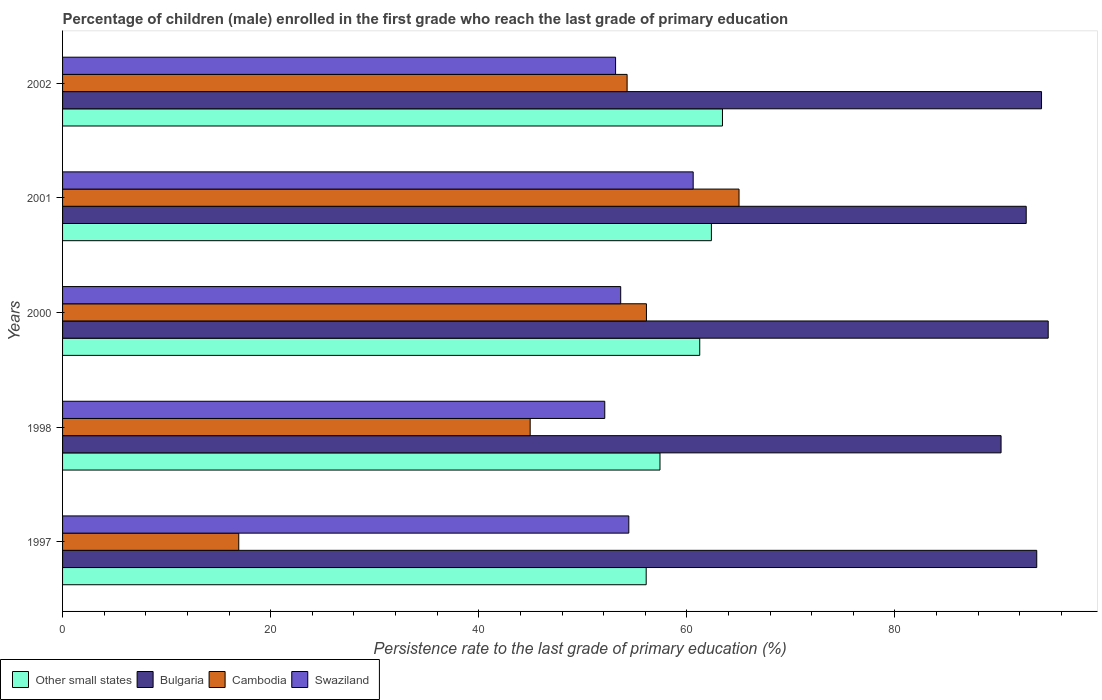How many different coloured bars are there?
Your response must be concise. 4. How many groups of bars are there?
Your response must be concise. 5. Are the number of bars per tick equal to the number of legend labels?
Offer a very short reply. Yes. Are the number of bars on each tick of the Y-axis equal?
Offer a terse response. Yes. What is the label of the 2nd group of bars from the top?
Your answer should be compact. 2001. In how many cases, is the number of bars for a given year not equal to the number of legend labels?
Offer a very short reply. 0. What is the persistence rate of children in Other small states in 1997?
Your answer should be compact. 56.09. Across all years, what is the maximum persistence rate of children in Cambodia?
Provide a succinct answer. 65.01. Across all years, what is the minimum persistence rate of children in Other small states?
Make the answer very short. 56.09. In which year was the persistence rate of children in Swaziland minimum?
Your response must be concise. 1998. What is the total persistence rate of children in Other small states in the graph?
Ensure brevity in your answer.  300.52. What is the difference between the persistence rate of children in Bulgaria in 2000 and that in 2002?
Offer a very short reply. 0.64. What is the difference between the persistence rate of children in Bulgaria in 1997 and the persistence rate of children in Cambodia in 2001?
Provide a short and direct response. 28.61. What is the average persistence rate of children in Other small states per year?
Your response must be concise. 60.1. In the year 1998, what is the difference between the persistence rate of children in Swaziland and persistence rate of children in Other small states?
Give a very brief answer. -5.31. In how many years, is the persistence rate of children in Bulgaria greater than 52 %?
Provide a short and direct response. 5. What is the ratio of the persistence rate of children in Cambodia in 1998 to that in 2000?
Your response must be concise. 0.8. Is the difference between the persistence rate of children in Swaziland in 2000 and 2001 greater than the difference between the persistence rate of children in Other small states in 2000 and 2001?
Make the answer very short. No. What is the difference between the highest and the second highest persistence rate of children in Other small states?
Ensure brevity in your answer.  1.07. What is the difference between the highest and the lowest persistence rate of children in Swaziland?
Offer a very short reply. 8.5. Is the sum of the persistence rate of children in Cambodia in 1997 and 1998 greater than the maximum persistence rate of children in Other small states across all years?
Give a very brief answer. No. What does the 3rd bar from the top in 1998 represents?
Give a very brief answer. Bulgaria. Is it the case that in every year, the sum of the persistence rate of children in Other small states and persistence rate of children in Bulgaria is greater than the persistence rate of children in Cambodia?
Provide a short and direct response. Yes. What is the difference between two consecutive major ticks on the X-axis?
Keep it short and to the point. 20. Are the values on the major ticks of X-axis written in scientific E-notation?
Your answer should be compact. No. Does the graph contain any zero values?
Offer a very short reply. No. How many legend labels are there?
Provide a succinct answer. 4. What is the title of the graph?
Make the answer very short. Percentage of children (male) enrolled in the first grade who reach the last grade of primary education. Does "Suriname" appear as one of the legend labels in the graph?
Keep it short and to the point. No. What is the label or title of the X-axis?
Provide a succinct answer. Persistence rate to the last grade of primary education (%). What is the Persistence rate to the last grade of primary education (%) of Other small states in 1997?
Provide a succinct answer. 56.09. What is the Persistence rate to the last grade of primary education (%) of Bulgaria in 1997?
Offer a terse response. 93.63. What is the Persistence rate to the last grade of primary education (%) of Cambodia in 1997?
Your response must be concise. 16.93. What is the Persistence rate to the last grade of primary education (%) of Swaziland in 1997?
Your answer should be very brief. 54.42. What is the Persistence rate to the last grade of primary education (%) of Other small states in 1998?
Keep it short and to the point. 57.42. What is the Persistence rate to the last grade of primary education (%) in Bulgaria in 1998?
Your answer should be compact. 90.2. What is the Persistence rate to the last grade of primary education (%) in Cambodia in 1998?
Provide a short and direct response. 44.94. What is the Persistence rate to the last grade of primary education (%) in Swaziland in 1998?
Provide a succinct answer. 52.11. What is the Persistence rate to the last grade of primary education (%) of Other small states in 2000?
Give a very brief answer. 61.24. What is the Persistence rate to the last grade of primary education (%) of Bulgaria in 2000?
Your answer should be compact. 94.73. What is the Persistence rate to the last grade of primary education (%) in Cambodia in 2000?
Make the answer very short. 56.11. What is the Persistence rate to the last grade of primary education (%) in Swaziland in 2000?
Provide a succinct answer. 53.64. What is the Persistence rate to the last grade of primary education (%) in Other small states in 2001?
Your response must be concise. 62.36. What is the Persistence rate to the last grade of primary education (%) of Bulgaria in 2001?
Your answer should be compact. 92.61. What is the Persistence rate to the last grade of primary education (%) in Cambodia in 2001?
Offer a very short reply. 65.01. What is the Persistence rate to the last grade of primary education (%) in Swaziland in 2001?
Provide a short and direct response. 60.61. What is the Persistence rate to the last grade of primary education (%) in Other small states in 2002?
Provide a short and direct response. 63.42. What is the Persistence rate to the last grade of primary education (%) of Bulgaria in 2002?
Offer a very short reply. 94.09. What is the Persistence rate to the last grade of primary education (%) in Cambodia in 2002?
Make the answer very short. 54.26. What is the Persistence rate to the last grade of primary education (%) of Swaziland in 2002?
Provide a succinct answer. 53.15. Across all years, what is the maximum Persistence rate to the last grade of primary education (%) of Other small states?
Your answer should be compact. 63.42. Across all years, what is the maximum Persistence rate to the last grade of primary education (%) of Bulgaria?
Provide a short and direct response. 94.73. Across all years, what is the maximum Persistence rate to the last grade of primary education (%) in Cambodia?
Provide a short and direct response. 65.01. Across all years, what is the maximum Persistence rate to the last grade of primary education (%) of Swaziland?
Your response must be concise. 60.61. Across all years, what is the minimum Persistence rate to the last grade of primary education (%) of Other small states?
Make the answer very short. 56.09. Across all years, what is the minimum Persistence rate to the last grade of primary education (%) in Bulgaria?
Make the answer very short. 90.2. Across all years, what is the minimum Persistence rate to the last grade of primary education (%) of Cambodia?
Your response must be concise. 16.93. Across all years, what is the minimum Persistence rate to the last grade of primary education (%) in Swaziland?
Give a very brief answer. 52.11. What is the total Persistence rate to the last grade of primary education (%) of Other small states in the graph?
Ensure brevity in your answer.  300.52. What is the total Persistence rate to the last grade of primary education (%) in Bulgaria in the graph?
Keep it short and to the point. 465.25. What is the total Persistence rate to the last grade of primary education (%) in Cambodia in the graph?
Keep it short and to the point. 237.26. What is the total Persistence rate to the last grade of primary education (%) of Swaziland in the graph?
Your answer should be compact. 273.93. What is the difference between the Persistence rate to the last grade of primary education (%) of Other small states in 1997 and that in 1998?
Ensure brevity in your answer.  -1.33. What is the difference between the Persistence rate to the last grade of primary education (%) in Bulgaria in 1997 and that in 1998?
Provide a succinct answer. 3.43. What is the difference between the Persistence rate to the last grade of primary education (%) in Cambodia in 1997 and that in 1998?
Your answer should be very brief. -28.01. What is the difference between the Persistence rate to the last grade of primary education (%) in Swaziland in 1997 and that in 1998?
Your answer should be very brief. 2.31. What is the difference between the Persistence rate to the last grade of primary education (%) in Other small states in 1997 and that in 2000?
Give a very brief answer. -5.15. What is the difference between the Persistence rate to the last grade of primary education (%) of Bulgaria in 1997 and that in 2000?
Your response must be concise. -1.1. What is the difference between the Persistence rate to the last grade of primary education (%) of Cambodia in 1997 and that in 2000?
Your answer should be very brief. -39.18. What is the difference between the Persistence rate to the last grade of primary education (%) in Swaziland in 1997 and that in 2000?
Your answer should be compact. 0.78. What is the difference between the Persistence rate to the last grade of primary education (%) of Other small states in 1997 and that in 2001?
Keep it short and to the point. -6.27. What is the difference between the Persistence rate to the last grade of primary education (%) of Bulgaria in 1997 and that in 2001?
Provide a short and direct response. 1.01. What is the difference between the Persistence rate to the last grade of primary education (%) of Cambodia in 1997 and that in 2001?
Offer a very short reply. -48.08. What is the difference between the Persistence rate to the last grade of primary education (%) of Swaziland in 1997 and that in 2001?
Offer a very short reply. -6.19. What is the difference between the Persistence rate to the last grade of primary education (%) of Other small states in 1997 and that in 2002?
Offer a terse response. -7.33. What is the difference between the Persistence rate to the last grade of primary education (%) of Bulgaria in 1997 and that in 2002?
Ensure brevity in your answer.  -0.46. What is the difference between the Persistence rate to the last grade of primary education (%) in Cambodia in 1997 and that in 2002?
Give a very brief answer. -37.32. What is the difference between the Persistence rate to the last grade of primary education (%) of Swaziland in 1997 and that in 2002?
Make the answer very short. 1.27. What is the difference between the Persistence rate to the last grade of primary education (%) in Other small states in 1998 and that in 2000?
Ensure brevity in your answer.  -3.82. What is the difference between the Persistence rate to the last grade of primary education (%) of Bulgaria in 1998 and that in 2000?
Ensure brevity in your answer.  -4.53. What is the difference between the Persistence rate to the last grade of primary education (%) of Cambodia in 1998 and that in 2000?
Your answer should be very brief. -11.17. What is the difference between the Persistence rate to the last grade of primary education (%) in Swaziland in 1998 and that in 2000?
Make the answer very short. -1.53. What is the difference between the Persistence rate to the last grade of primary education (%) in Other small states in 1998 and that in 2001?
Your response must be concise. -4.94. What is the difference between the Persistence rate to the last grade of primary education (%) in Bulgaria in 1998 and that in 2001?
Your answer should be very brief. -2.42. What is the difference between the Persistence rate to the last grade of primary education (%) of Cambodia in 1998 and that in 2001?
Provide a short and direct response. -20.07. What is the difference between the Persistence rate to the last grade of primary education (%) of Swaziland in 1998 and that in 2001?
Keep it short and to the point. -8.5. What is the difference between the Persistence rate to the last grade of primary education (%) of Other small states in 1998 and that in 2002?
Provide a succinct answer. -6. What is the difference between the Persistence rate to the last grade of primary education (%) of Bulgaria in 1998 and that in 2002?
Provide a short and direct response. -3.89. What is the difference between the Persistence rate to the last grade of primary education (%) of Cambodia in 1998 and that in 2002?
Keep it short and to the point. -9.32. What is the difference between the Persistence rate to the last grade of primary education (%) in Swaziland in 1998 and that in 2002?
Offer a terse response. -1.04. What is the difference between the Persistence rate to the last grade of primary education (%) in Other small states in 2000 and that in 2001?
Offer a terse response. -1.12. What is the difference between the Persistence rate to the last grade of primary education (%) in Bulgaria in 2000 and that in 2001?
Your response must be concise. 2.11. What is the difference between the Persistence rate to the last grade of primary education (%) in Cambodia in 2000 and that in 2001?
Provide a short and direct response. -8.9. What is the difference between the Persistence rate to the last grade of primary education (%) of Swaziland in 2000 and that in 2001?
Provide a succinct answer. -6.97. What is the difference between the Persistence rate to the last grade of primary education (%) in Other small states in 2000 and that in 2002?
Offer a terse response. -2.18. What is the difference between the Persistence rate to the last grade of primary education (%) of Bulgaria in 2000 and that in 2002?
Make the answer very short. 0.64. What is the difference between the Persistence rate to the last grade of primary education (%) in Cambodia in 2000 and that in 2002?
Give a very brief answer. 1.86. What is the difference between the Persistence rate to the last grade of primary education (%) of Swaziland in 2000 and that in 2002?
Give a very brief answer. 0.49. What is the difference between the Persistence rate to the last grade of primary education (%) of Other small states in 2001 and that in 2002?
Provide a short and direct response. -1.07. What is the difference between the Persistence rate to the last grade of primary education (%) in Bulgaria in 2001 and that in 2002?
Your answer should be very brief. -1.47. What is the difference between the Persistence rate to the last grade of primary education (%) in Cambodia in 2001 and that in 2002?
Your answer should be compact. 10.76. What is the difference between the Persistence rate to the last grade of primary education (%) in Swaziland in 2001 and that in 2002?
Offer a very short reply. 7.46. What is the difference between the Persistence rate to the last grade of primary education (%) of Other small states in 1997 and the Persistence rate to the last grade of primary education (%) of Bulgaria in 1998?
Give a very brief answer. -34.11. What is the difference between the Persistence rate to the last grade of primary education (%) of Other small states in 1997 and the Persistence rate to the last grade of primary education (%) of Cambodia in 1998?
Make the answer very short. 11.15. What is the difference between the Persistence rate to the last grade of primary education (%) of Other small states in 1997 and the Persistence rate to the last grade of primary education (%) of Swaziland in 1998?
Ensure brevity in your answer.  3.98. What is the difference between the Persistence rate to the last grade of primary education (%) in Bulgaria in 1997 and the Persistence rate to the last grade of primary education (%) in Cambodia in 1998?
Offer a terse response. 48.69. What is the difference between the Persistence rate to the last grade of primary education (%) in Bulgaria in 1997 and the Persistence rate to the last grade of primary education (%) in Swaziland in 1998?
Your response must be concise. 41.52. What is the difference between the Persistence rate to the last grade of primary education (%) of Cambodia in 1997 and the Persistence rate to the last grade of primary education (%) of Swaziland in 1998?
Your answer should be very brief. -35.18. What is the difference between the Persistence rate to the last grade of primary education (%) of Other small states in 1997 and the Persistence rate to the last grade of primary education (%) of Bulgaria in 2000?
Make the answer very short. -38.64. What is the difference between the Persistence rate to the last grade of primary education (%) of Other small states in 1997 and the Persistence rate to the last grade of primary education (%) of Cambodia in 2000?
Ensure brevity in your answer.  -0.02. What is the difference between the Persistence rate to the last grade of primary education (%) of Other small states in 1997 and the Persistence rate to the last grade of primary education (%) of Swaziland in 2000?
Keep it short and to the point. 2.45. What is the difference between the Persistence rate to the last grade of primary education (%) of Bulgaria in 1997 and the Persistence rate to the last grade of primary education (%) of Cambodia in 2000?
Provide a succinct answer. 37.51. What is the difference between the Persistence rate to the last grade of primary education (%) of Bulgaria in 1997 and the Persistence rate to the last grade of primary education (%) of Swaziland in 2000?
Make the answer very short. 39.99. What is the difference between the Persistence rate to the last grade of primary education (%) in Cambodia in 1997 and the Persistence rate to the last grade of primary education (%) in Swaziland in 2000?
Your response must be concise. -36.71. What is the difference between the Persistence rate to the last grade of primary education (%) in Other small states in 1997 and the Persistence rate to the last grade of primary education (%) in Bulgaria in 2001?
Provide a succinct answer. -36.52. What is the difference between the Persistence rate to the last grade of primary education (%) in Other small states in 1997 and the Persistence rate to the last grade of primary education (%) in Cambodia in 2001?
Ensure brevity in your answer.  -8.92. What is the difference between the Persistence rate to the last grade of primary education (%) of Other small states in 1997 and the Persistence rate to the last grade of primary education (%) of Swaziland in 2001?
Your answer should be compact. -4.52. What is the difference between the Persistence rate to the last grade of primary education (%) in Bulgaria in 1997 and the Persistence rate to the last grade of primary education (%) in Cambodia in 2001?
Offer a very short reply. 28.61. What is the difference between the Persistence rate to the last grade of primary education (%) in Bulgaria in 1997 and the Persistence rate to the last grade of primary education (%) in Swaziland in 2001?
Ensure brevity in your answer.  33.02. What is the difference between the Persistence rate to the last grade of primary education (%) in Cambodia in 1997 and the Persistence rate to the last grade of primary education (%) in Swaziland in 2001?
Provide a succinct answer. -43.67. What is the difference between the Persistence rate to the last grade of primary education (%) in Other small states in 1997 and the Persistence rate to the last grade of primary education (%) in Bulgaria in 2002?
Offer a terse response. -38. What is the difference between the Persistence rate to the last grade of primary education (%) of Other small states in 1997 and the Persistence rate to the last grade of primary education (%) of Cambodia in 2002?
Provide a short and direct response. 1.83. What is the difference between the Persistence rate to the last grade of primary education (%) of Other small states in 1997 and the Persistence rate to the last grade of primary education (%) of Swaziland in 2002?
Your answer should be compact. 2.94. What is the difference between the Persistence rate to the last grade of primary education (%) in Bulgaria in 1997 and the Persistence rate to the last grade of primary education (%) in Cambodia in 2002?
Your answer should be very brief. 39.37. What is the difference between the Persistence rate to the last grade of primary education (%) of Bulgaria in 1997 and the Persistence rate to the last grade of primary education (%) of Swaziland in 2002?
Ensure brevity in your answer.  40.48. What is the difference between the Persistence rate to the last grade of primary education (%) of Cambodia in 1997 and the Persistence rate to the last grade of primary education (%) of Swaziland in 2002?
Make the answer very short. -36.21. What is the difference between the Persistence rate to the last grade of primary education (%) of Other small states in 1998 and the Persistence rate to the last grade of primary education (%) of Bulgaria in 2000?
Your response must be concise. -37.31. What is the difference between the Persistence rate to the last grade of primary education (%) in Other small states in 1998 and the Persistence rate to the last grade of primary education (%) in Cambodia in 2000?
Your answer should be compact. 1.3. What is the difference between the Persistence rate to the last grade of primary education (%) in Other small states in 1998 and the Persistence rate to the last grade of primary education (%) in Swaziland in 2000?
Ensure brevity in your answer.  3.78. What is the difference between the Persistence rate to the last grade of primary education (%) of Bulgaria in 1998 and the Persistence rate to the last grade of primary education (%) of Cambodia in 2000?
Give a very brief answer. 34.08. What is the difference between the Persistence rate to the last grade of primary education (%) in Bulgaria in 1998 and the Persistence rate to the last grade of primary education (%) in Swaziland in 2000?
Offer a terse response. 36.56. What is the difference between the Persistence rate to the last grade of primary education (%) of Cambodia in 1998 and the Persistence rate to the last grade of primary education (%) of Swaziland in 2000?
Provide a short and direct response. -8.7. What is the difference between the Persistence rate to the last grade of primary education (%) in Other small states in 1998 and the Persistence rate to the last grade of primary education (%) in Bulgaria in 2001?
Your response must be concise. -35.2. What is the difference between the Persistence rate to the last grade of primary education (%) in Other small states in 1998 and the Persistence rate to the last grade of primary education (%) in Cambodia in 2001?
Offer a terse response. -7.6. What is the difference between the Persistence rate to the last grade of primary education (%) of Other small states in 1998 and the Persistence rate to the last grade of primary education (%) of Swaziland in 2001?
Keep it short and to the point. -3.19. What is the difference between the Persistence rate to the last grade of primary education (%) in Bulgaria in 1998 and the Persistence rate to the last grade of primary education (%) in Cambodia in 2001?
Your response must be concise. 25.18. What is the difference between the Persistence rate to the last grade of primary education (%) of Bulgaria in 1998 and the Persistence rate to the last grade of primary education (%) of Swaziland in 2001?
Ensure brevity in your answer.  29.59. What is the difference between the Persistence rate to the last grade of primary education (%) in Cambodia in 1998 and the Persistence rate to the last grade of primary education (%) in Swaziland in 2001?
Your response must be concise. -15.67. What is the difference between the Persistence rate to the last grade of primary education (%) of Other small states in 1998 and the Persistence rate to the last grade of primary education (%) of Bulgaria in 2002?
Provide a short and direct response. -36.67. What is the difference between the Persistence rate to the last grade of primary education (%) of Other small states in 1998 and the Persistence rate to the last grade of primary education (%) of Cambodia in 2002?
Provide a short and direct response. 3.16. What is the difference between the Persistence rate to the last grade of primary education (%) in Other small states in 1998 and the Persistence rate to the last grade of primary education (%) in Swaziland in 2002?
Give a very brief answer. 4.27. What is the difference between the Persistence rate to the last grade of primary education (%) in Bulgaria in 1998 and the Persistence rate to the last grade of primary education (%) in Cambodia in 2002?
Offer a terse response. 35.94. What is the difference between the Persistence rate to the last grade of primary education (%) in Bulgaria in 1998 and the Persistence rate to the last grade of primary education (%) in Swaziland in 2002?
Your response must be concise. 37.05. What is the difference between the Persistence rate to the last grade of primary education (%) of Cambodia in 1998 and the Persistence rate to the last grade of primary education (%) of Swaziland in 2002?
Offer a very short reply. -8.21. What is the difference between the Persistence rate to the last grade of primary education (%) of Other small states in 2000 and the Persistence rate to the last grade of primary education (%) of Bulgaria in 2001?
Offer a very short reply. -31.38. What is the difference between the Persistence rate to the last grade of primary education (%) of Other small states in 2000 and the Persistence rate to the last grade of primary education (%) of Cambodia in 2001?
Offer a very short reply. -3.78. What is the difference between the Persistence rate to the last grade of primary education (%) in Other small states in 2000 and the Persistence rate to the last grade of primary education (%) in Swaziland in 2001?
Your answer should be very brief. 0.63. What is the difference between the Persistence rate to the last grade of primary education (%) of Bulgaria in 2000 and the Persistence rate to the last grade of primary education (%) of Cambodia in 2001?
Ensure brevity in your answer.  29.71. What is the difference between the Persistence rate to the last grade of primary education (%) of Bulgaria in 2000 and the Persistence rate to the last grade of primary education (%) of Swaziland in 2001?
Give a very brief answer. 34.12. What is the difference between the Persistence rate to the last grade of primary education (%) in Cambodia in 2000 and the Persistence rate to the last grade of primary education (%) in Swaziland in 2001?
Keep it short and to the point. -4.49. What is the difference between the Persistence rate to the last grade of primary education (%) of Other small states in 2000 and the Persistence rate to the last grade of primary education (%) of Bulgaria in 2002?
Provide a short and direct response. -32.85. What is the difference between the Persistence rate to the last grade of primary education (%) in Other small states in 2000 and the Persistence rate to the last grade of primary education (%) in Cambodia in 2002?
Offer a terse response. 6.98. What is the difference between the Persistence rate to the last grade of primary education (%) of Other small states in 2000 and the Persistence rate to the last grade of primary education (%) of Swaziland in 2002?
Provide a succinct answer. 8.09. What is the difference between the Persistence rate to the last grade of primary education (%) of Bulgaria in 2000 and the Persistence rate to the last grade of primary education (%) of Cambodia in 2002?
Give a very brief answer. 40.47. What is the difference between the Persistence rate to the last grade of primary education (%) of Bulgaria in 2000 and the Persistence rate to the last grade of primary education (%) of Swaziland in 2002?
Your answer should be very brief. 41.58. What is the difference between the Persistence rate to the last grade of primary education (%) of Cambodia in 2000 and the Persistence rate to the last grade of primary education (%) of Swaziland in 2002?
Give a very brief answer. 2.97. What is the difference between the Persistence rate to the last grade of primary education (%) in Other small states in 2001 and the Persistence rate to the last grade of primary education (%) in Bulgaria in 2002?
Give a very brief answer. -31.73. What is the difference between the Persistence rate to the last grade of primary education (%) of Other small states in 2001 and the Persistence rate to the last grade of primary education (%) of Cambodia in 2002?
Your answer should be very brief. 8.1. What is the difference between the Persistence rate to the last grade of primary education (%) of Other small states in 2001 and the Persistence rate to the last grade of primary education (%) of Swaziland in 2002?
Make the answer very short. 9.21. What is the difference between the Persistence rate to the last grade of primary education (%) in Bulgaria in 2001 and the Persistence rate to the last grade of primary education (%) in Cambodia in 2002?
Your answer should be very brief. 38.36. What is the difference between the Persistence rate to the last grade of primary education (%) of Bulgaria in 2001 and the Persistence rate to the last grade of primary education (%) of Swaziland in 2002?
Your answer should be compact. 39.47. What is the difference between the Persistence rate to the last grade of primary education (%) of Cambodia in 2001 and the Persistence rate to the last grade of primary education (%) of Swaziland in 2002?
Your answer should be very brief. 11.86. What is the average Persistence rate to the last grade of primary education (%) of Other small states per year?
Ensure brevity in your answer.  60.1. What is the average Persistence rate to the last grade of primary education (%) of Bulgaria per year?
Provide a succinct answer. 93.05. What is the average Persistence rate to the last grade of primary education (%) in Cambodia per year?
Your answer should be very brief. 47.45. What is the average Persistence rate to the last grade of primary education (%) of Swaziland per year?
Offer a very short reply. 54.79. In the year 1997, what is the difference between the Persistence rate to the last grade of primary education (%) in Other small states and Persistence rate to the last grade of primary education (%) in Bulgaria?
Offer a terse response. -37.54. In the year 1997, what is the difference between the Persistence rate to the last grade of primary education (%) in Other small states and Persistence rate to the last grade of primary education (%) in Cambodia?
Give a very brief answer. 39.16. In the year 1997, what is the difference between the Persistence rate to the last grade of primary education (%) of Other small states and Persistence rate to the last grade of primary education (%) of Swaziland?
Your answer should be very brief. 1.67. In the year 1997, what is the difference between the Persistence rate to the last grade of primary education (%) in Bulgaria and Persistence rate to the last grade of primary education (%) in Cambodia?
Ensure brevity in your answer.  76.69. In the year 1997, what is the difference between the Persistence rate to the last grade of primary education (%) of Bulgaria and Persistence rate to the last grade of primary education (%) of Swaziland?
Your response must be concise. 39.21. In the year 1997, what is the difference between the Persistence rate to the last grade of primary education (%) of Cambodia and Persistence rate to the last grade of primary education (%) of Swaziland?
Keep it short and to the point. -37.49. In the year 1998, what is the difference between the Persistence rate to the last grade of primary education (%) of Other small states and Persistence rate to the last grade of primary education (%) of Bulgaria?
Offer a terse response. -32.78. In the year 1998, what is the difference between the Persistence rate to the last grade of primary education (%) of Other small states and Persistence rate to the last grade of primary education (%) of Cambodia?
Provide a short and direct response. 12.48. In the year 1998, what is the difference between the Persistence rate to the last grade of primary education (%) in Other small states and Persistence rate to the last grade of primary education (%) in Swaziland?
Provide a short and direct response. 5.31. In the year 1998, what is the difference between the Persistence rate to the last grade of primary education (%) in Bulgaria and Persistence rate to the last grade of primary education (%) in Cambodia?
Offer a very short reply. 45.26. In the year 1998, what is the difference between the Persistence rate to the last grade of primary education (%) in Bulgaria and Persistence rate to the last grade of primary education (%) in Swaziland?
Your answer should be compact. 38.09. In the year 1998, what is the difference between the Persistence rate to the last grade of primary education (%) in Cambodia and Persistence rate to the last grade of primary education (%) in Swaziland?
Provide a succinct answer. -7.17. In the year 2000, what is the difference between the Persistence rate to the last grade of primary education (%) in Other small states and Persistence rate to the last grade of primary education (%) in Bulgaria?
Provide a succinct answer. -33.49. In the year 2000, what is the difference between the Persistence rate to the last grade of primary education (%) in Other small states and Persistence rate to the last grade of primary education (%) in Cambodia?
Offer a very short reply. 5.12. In the year 2000, what is the difference between the Persistence rate to the last grade of primary education (%) of Other small states and Persistence rate to the last grade of primary education (%) of Swaziland?
Offer a terse response. 7.6. In the year 2000, what is the difference between the Persistence rate to the last grade of primary education (%) in Bulgaria and Persistence rate to the last grade of primary education (%) in Cambodia?
Offer a terse response. 38.61. In the year 2000, what is the difference between the Persistence rate to the last grade of primary education (%) in Bulgaria and Persistence rate to the last grade of primary education (%) in Swaziland?
Ensure brevity in your answer.  41.09. In the year 2000, what is the difference between the Persistence rate to the last grade of primary education (%) of Cambodia and Persistence rate to the last grade of primary education (%) of Swaziland?
Offer a very short reply. 2.47. In the year 2001, what is the difference between the Persistence rate to the last grade of primary education (%) of Other small states and Persistence rate to the last grade of primary education (%) of Bulgaria?
Your response must be concise. -30.26. In the year 2001, what is the difference between the Persistence rate to the last grade of primary education (%) of Other small states and Persistence rate to the last grade of primary education (%) of Cambodia?
Offer a very short reply. -2.66. In the year 2001, what is the difference between the Persistence rate to the last grade of primary education (%) in Other small states and Persistence rate to the last grade of primary education (%) in Swaziland?
Make the answer very short. 1.75. In the year 2001, what is the difference between the Persistence rate to the last grade of primary education (%) of Bulgaria and Persistence rate to the last grade of primary education (%) of Cambodia?
Your response must be concise. 27.6. In the year 2001, what is the difference between the Persistence rate to the last grade of primary education (%) in Bulgaria and Persistence rate to the last grade of primary education (%) in Swaziland?
Provide a short and direct response. 32.01. In the year 2001, what is the difference between the Persistence rate to the last grade of primary education (%) in Cambodia and Persistence rate to the last grade of primary education (%) in Swaziland?
Make the answer very short. 4.41. In the year 2002, what is the difference between the Persistence rate to the last grade of primary education (%) of Other small states and Persistence rate to the last grade of primary education (%) of Bulgaria?
Offer a very short reply. -30.66. In the year 2002, what is the difference between the Persistence rate to the last grade of primary education (%) of Other small states and Persistence rate to the last grade of primary education (%) of Cambodia?
Keep it short and to the point. 9.16. In the year 2002, what is the difference between the Persistence rate to the last grade of primary education (%) in Other small states and Persistence rate to the last grade of primary education (%) in Swaziland?
Provide a short and direct response. 10.27. In the year 2002, what is the difference between the Persistence rate to the last grade of primary education (%) in Bulgaria and Persistence rate to the last grade of primary education (%) in Cambodia?
Make the answer very short. 39.83. In the year 2002, what is the difference between the Persistence rate to the last grade of primary education (%) of Bulgaria and Persistence rate to the last grade of primary education (%) of Swaziland?
Make the answer very short. 40.94. In the year 2002, what is the difference between the Persistence rate to the last grade of primary education (%) in Cambodia and Persistence rate to the last grade of primary education (%) in Swaziland?
Make the answer very short. 1.11. What is the ratio of the Persistence rate to the last grade of primary education (%) in Other small states in 1997 to that in 1998?
Your answer should be very brief. 0.98. What is the ratio of the Persistence rate to the last grade of primary education (%) of Bulgaria in 1997 to that in 1998?
Ensure brevity in your answer.  1.04. What is the ratio of the Persistence rate to the last grade of primary education (%) in Cambodia in 1997 to that in 1998?
Offer a terse response. 0.38. What is the ratio of the Persistence rate to the last grade of primary education (%) of Swaziland in 1997 to that in 1998?
Provide a short and direct response. 1.04. What is the ratio of the Persistence rate to the last grade of primary education (%) of Other small states in 1997 to that in 2000?
Keep it short and to the point. 0.92. What is the ratio of the Persistence rate to the last grade of primary education (%) in Bulgaria in 1997 to that in 2000?
Provide a succinct answer. 0.99. What is the ratio of the Persistence rate to the last grade of primary education (%) of Cambodia in 1997 to that in 2000?
Give a very brief answer. 0.3. What is the ratio of the Persistence rate to the last grade of primary education (%) in Swaziland in 1997 to that in 2000?
Provide a short and direct response. 1.01. What is the ratio of the Persistence rate to the last grade of primary education (%) of Other small states in 1997 to that in 2001?
Make the answer very short. 0.9. What is the ratio of the Persistence rate to the last grade of primary education (%) in Bulgaria in 1997 to that in 2001?
Your response must be concise. 1.01. What is the ratio of the Persistence rate to the last grade of primary education (%) in Cambodia in 1997 to that in 2001?
Your answer should be very brief. 0.26. What is the ratio of the Persistence rate to the last grade of primary education (%) in Swaziland in 1997 to that in 2001?
Your response must be concise. 0.9. What is the ratio of the Persistence rate to the last grade of primary education (%) of Other small states in 1997 to that in 2002?
Provide a succinct answer. 0.88. What is the ratio of the Persistence rate to the last grade of primary education (%) of Cambodia in 1997 to that in 2002?
Your answer should be compact. 0.31. What is the ratio of the Persistence rate to the last grade of primary education (%) of Swaziland in 1997 to that in 2002?
Your answer should be compact. 1.02. What is the ratio of the Persistence rate to the last grade of primary education (%) of Other small states in 1998 to that in 2000?
Your answer should be compact. 0.94. What is the ratio of the Persistence rate to the last grade of primary education (%) of Bulgaria in 1998 to that in 2000?
Provide a short and direct response. 0.95. What is the ratio of the Persistence rate to the last grade of primary education (%) of Cambodia in 1998 to that in 2000?
Offer a very short reply. 0.8. What is the ratio of the Persistence rate to the last grade of primary education (%) in Swaziland in 1998 to that in 2000?
Your answer should be compact. 0.97. What is the ratio of the Persistence rate to the last grade of primary education (%) in Other small states in 1998 to that in 2001?
Give a very brief answer. 0.92. What is the ratio of the Persistence rate to the last grade of primary education (%) in Bulgaria in 1998 to that in 2001?
Provide a short and direct response. 0.97. What is the ratio of the Persistence rate to the last grade of primary education (%) in Cambodia in 1998 to that in 2001?
Your response must be concise. 0.69. What is the ratio of the Persistence rate to the last grade of primary education (%) in Swaziland in 1998 to that in 2001?
Your answer should be very brief. 0.86. What is the ratio of the Persistence rate to the last grade of primary education (%) of Other small states in 1998 to that in 2002?
Your answer should be compact. 0.91. What is the ratio of the Persistence rate to the last grade of primary education (%) of Bulgaria in 1998 to that in 2002?
Provide a short and direct response. 0.96. What is the ratio of the Persistence rate to the last grade of primary education (%) of Cambodia in 1998 to that in 2002?
Keep it short and to the point. 0.83. What is the ratio of the Persistence rate to the last grade of primary education (%) in Swaziland in 1998 to that in 2002?
Make the answer very short. 0.98. What is the ratio of the Persistence rate to the last grade of primary education (%) in Other small states in 2000 to that in 2001?
Provide a short and direct response. 0.98. What is the ratio of the Persistence rate to the last grade of primary education (%) in Bulgaria in 2000 to that in 2001?
Provide a succinct answer. 1.02. What is the ratio of the Persistence rate to the last grade of primary education (%) of Cambodia in 2000 to that in 2001?
Your answer should be very brief. 0.86. What is the ratio of the Persistence rate to the last grade of primary education (%) in Swaziland in 2000 to that in 2001?
Make the answer very short. 0.89. What is the ratio of the Persistence rate to the last grade of primary education (%) of Other small states in 2000 to that in 2002?
Ensure brevity in your answer.  0.97. What is the ratio of the Persistence rate to the last grade of primary education (%) of Bulgaria in 2000 to that in 2002?
Provide a short and direct response. 1.01. What is the ratio of the Persistence rate to the last grade of primary education (%) of Cambodia in 2000 to that in 2002?
Offer a very short reply. 1.03. What is the ratio of the Persistence rate to the last grade of primary education (%) of Swaziland in 2000 to that in 2002?
Your response must be concise. 1.01. What is the ratio of the Persistence rate to the last grade of primary education (%) in Other small states in 2001 to that in 2002?
Your answer should be compact. 0.98. What is the ratio of the Persistence rate to the last grade of primary education (%) of Bulgaria in 2001 to that in 2002?
Make the answer very short. 0.98. What is the ratio of the Persistence rate to the last grade of primary education (%) in Cambodia in 2001 to that in 2002?
Make the answer very short. 1.2. What is the ratio of the Persistence rate to the last grade of primary education (%) in Swaziland in 2001 to that in 2002?
Your answer should be compact. 1.14. What is the difference between the highest and the second highest Persistence rate to the last grade of primary education (%) in Other small states?
Your response must be concise. 1.07. What is the difference between the highest and the second highest Persistence rate to the last grade of primary education (%) in Bulgaria?
Your answer should be very brief. 0.64. What is the difference between the highest and the second highest Persistence rate to the last grade of primary education (%) of Cambodia?
Provide a short and direct response. 8.9. What is the difference between the highest and the second highest Persistence rate to the last grade of primary education (%) in Swaziland?
Provide a succinct answer. 6.19. What is the difference between the highest and the lowest Persistence rate to the last grade of primary education (%) of Other small states?
Give a very brief answer. 7.33. What is the difference between the highest and the lowest Persistence rate to the last grade of primary education (%) of Bulgaria?
Ensure brevity in your answer.  4.53. What is the difference between the highest and the lowest Persistence rate to the last grade of primary education (%) in Cambodia?
Your response must be concise. 48.08. What is the difference between the highest and the lowest Persistence rate to the last grade of primary education (%) of Swaziland?
Your answer should be very brief. 8.5. 